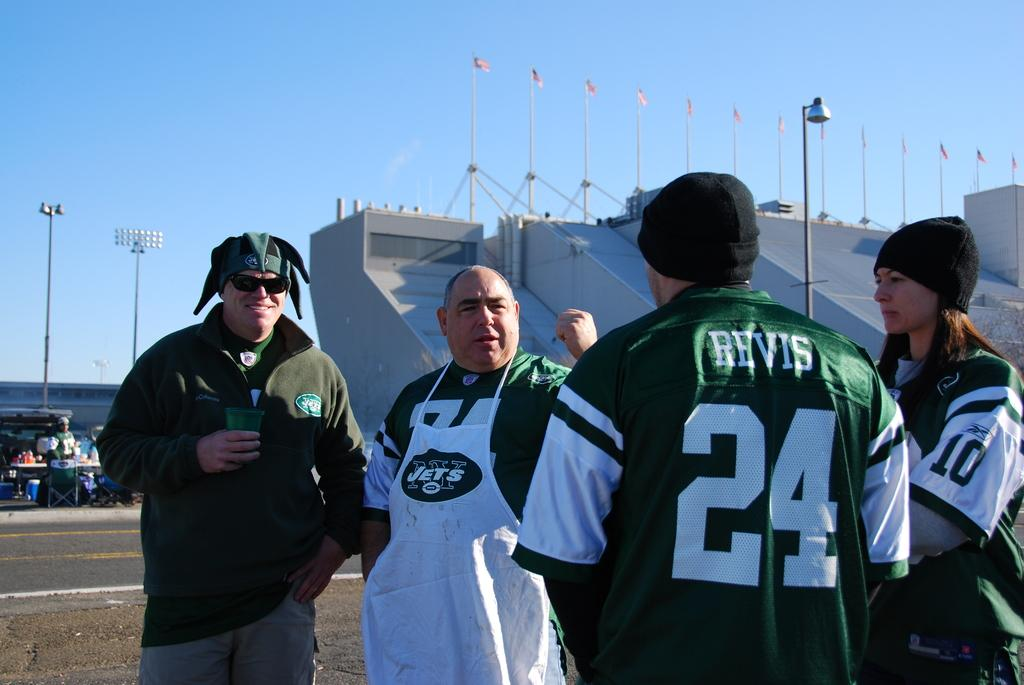<image>
Create a compact narrative representing the image presented. Four Jets fans are hanging out including one with a Revis 24 jersey on. 